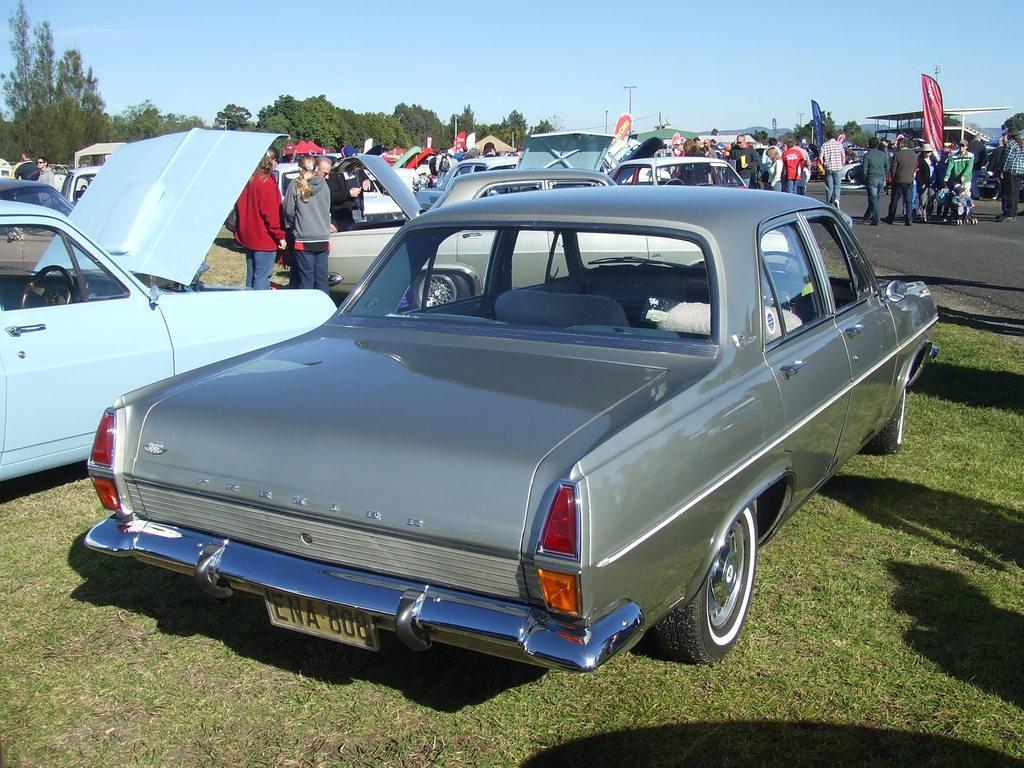Please provide a concise description of this image. In the center of the image there are cars and we can see people. There is a road. At the bottom we can see grass. In the background there are trees, poles, shed and sky. 